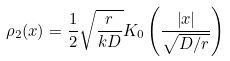Convert formula to latex. <formula><loc_0><loc_0><loc_500><loc_500>\rho _ { 2 } ( x ) = \frac { 1 } { 2 } \sqrt { \frac { r } { k D } } K _ { 0 } \left ( \frac { \left | x \right | } { \sqrt { D / r } } \right )</formula> 